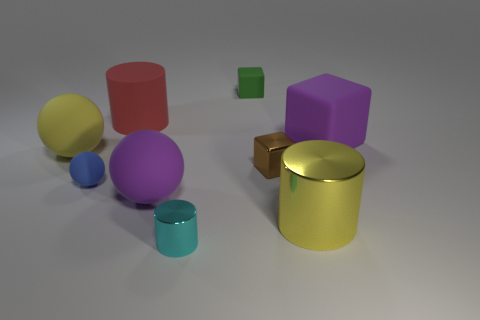Subtract 1 spheres. How many spheres are left? 2 Subtract all large rubber cubes. How many cubes are left? 2 Subtract all cylinders. How many objects are left? 6 Subtract all tiny blue rubber things. Subtract all cylinders. How many objects are left? 5 Add 7 large yellow shiny cylinders. How many large yellow shiny cylinders are left? 8 Add 8 brown blocks. How many brown blocks exist? 9 Subtract 0 blue cylinders. How many objects are left? 9 